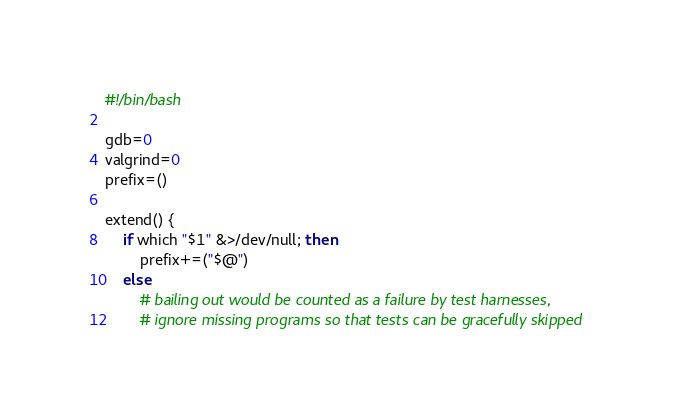<code> <loc_0><loc_0><loc_500><loc_500><_Bash_>#!/bin/bash

gdb=0
valgrind=0
prefix=()

extend() {
    if which "$1" &>/dev/null; then
        prefix+=("$@")
    else
        # bailing out would be counted as a failure by test harnesses,
        # ignore missing programs so that tests can be gracefully skipped</code> 